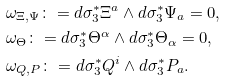Convert formula to latex. <formula><loc_0><loc_0><loc_500><loc_500>& \omega _ { \Xi , \Psi } \colon = d \sigma _ { 3 } ^ { * } \Xi ^ { a } \wedge d \sigma _ { 3 } ^ { * } \Psi _ { a } = 0 , \\ & \omega _ { \Theta } \colon = d \sigma _ { 3 } ^ { * } \Theta ^ { \alpha } \wedge d \sigma _ { 3 } ^ { * } \Theta _ { \alpha } = 0 , \\ & \omega _ { Q , P } \colon = d \sigma _ { 3 } ^ { * } Q ^ { i } \wedge d \sigma _ { 3 } ^ { * } P _ { a } .</formula> 